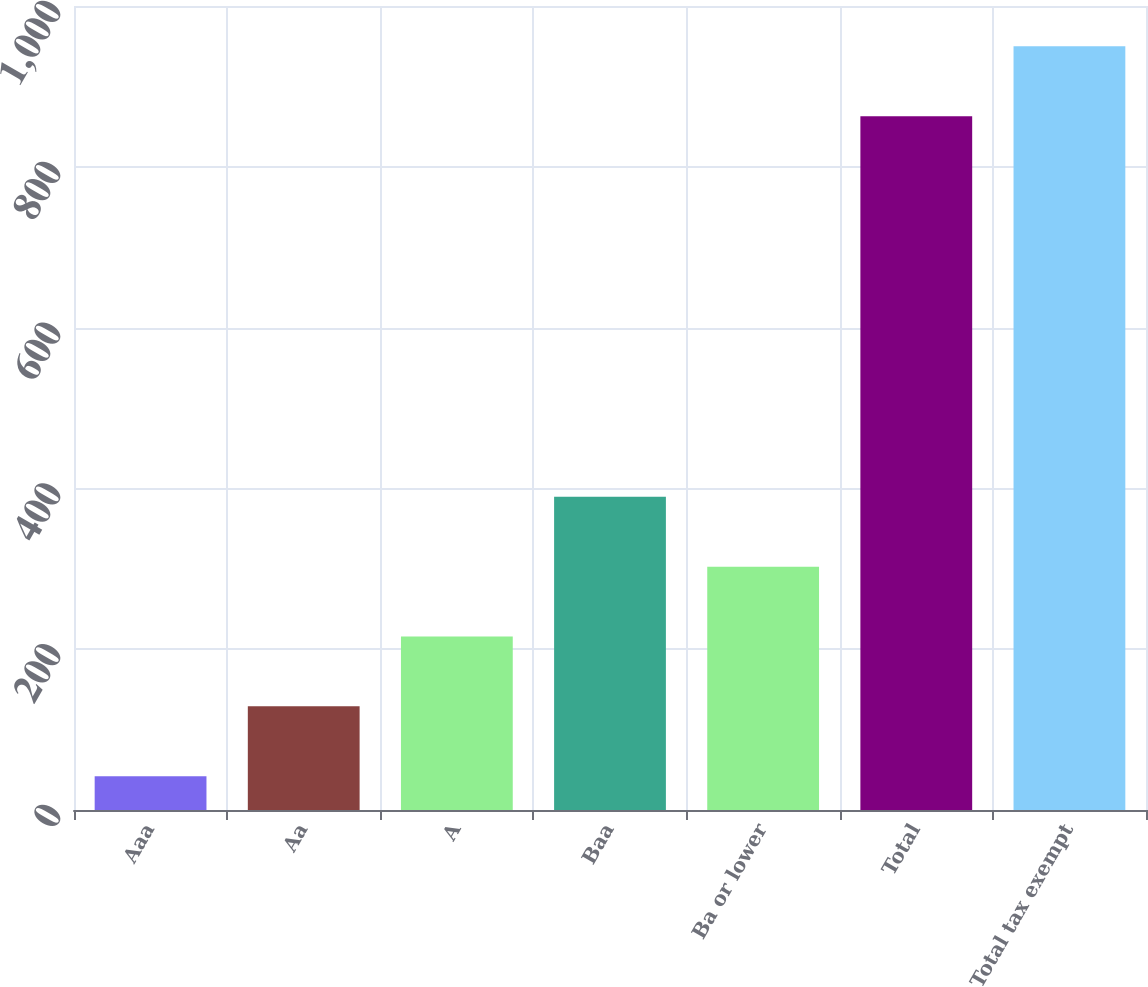Convert chart to OTSL. <chart><loc_0><loc_0><loc_500><loc_500><bar_chart><fcel>Aaa<fcel>Aa<fcel>A<fcel>Baa<fcel>Ba or lower<fcel>Total<fcel>Total tax exempt<nl><fcel>42<fcel>128.9<fcel>215.8<fcel>389.6<fcel>302.7<fcel>863<fcel>949.9<nl></chart> 